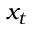Convert formula to latex. <formula><loc_0><loc_0><loc_500><loc_500>x _ { t }</formula> 